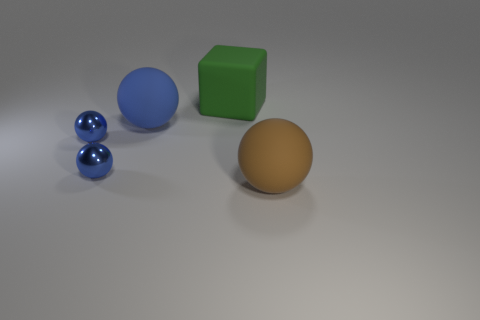Subtract all blue spheres. How many were subtracted if there are1blue spheres left? 2 Subtract all green blocks. How many blue balls are left? 3 Add 3 tiny cyan metallic blocks. How many objects exist? 8 Subtract all spheres. How many objects are left? 1 Subtract 0 red balls. How many objects are left? 5 Subtract all tiny blue shiny objects. Subtract all big blue rubber spheres. How many objects are left? 2 Add 2 big brown spheres. How many big brown spheres are left? 3 Add 4 metal spheres. How many metal spheres exist? 6 